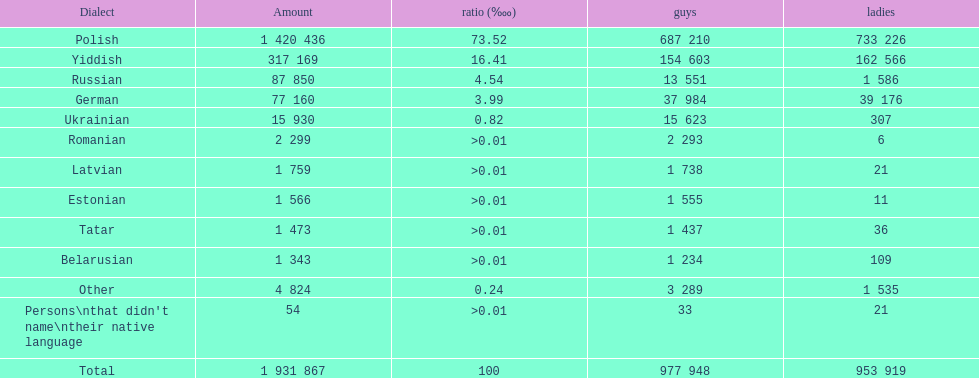Which language had the least female speakers? Romanian. 